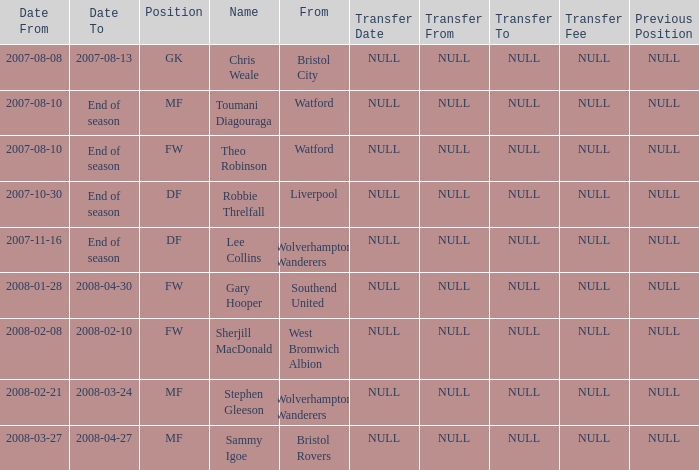From which place was the df-positioned player, who commenced on 2007-10-30, hailing? Liverpool. 